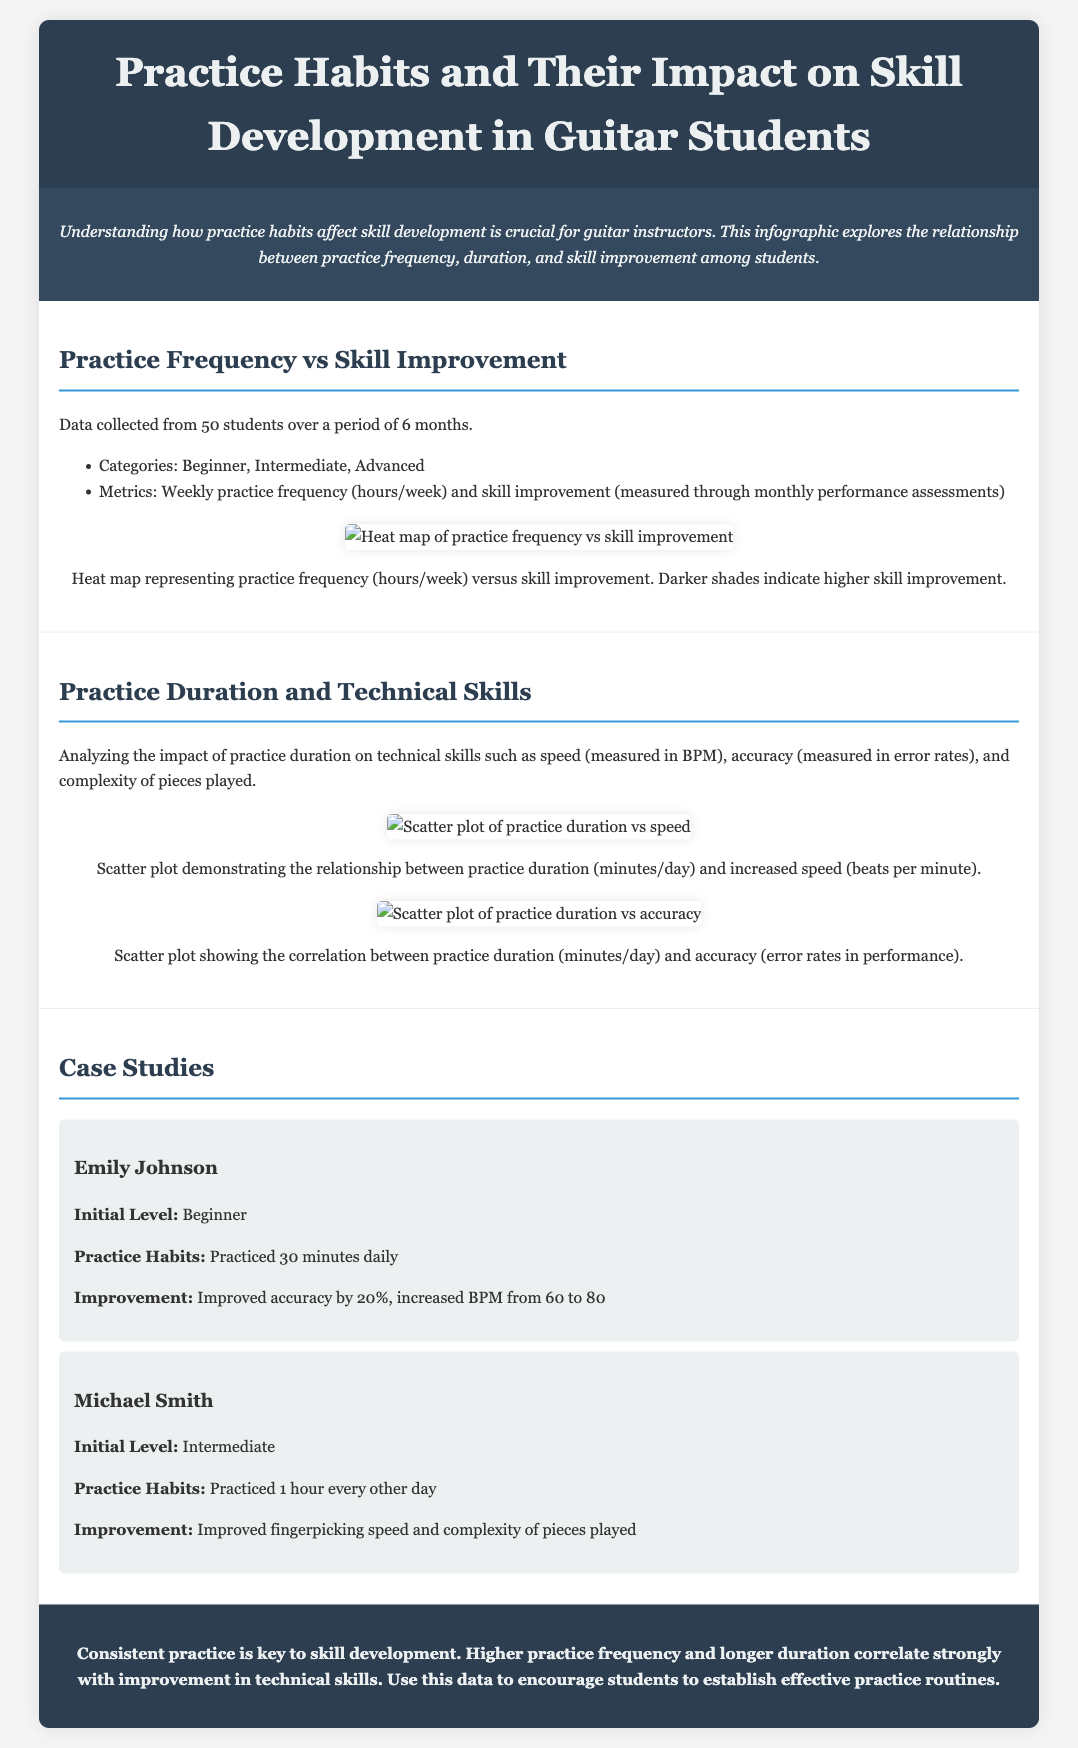what is the title of the infographic? The title of the infographic is stated in the header section, which summarizes the main topic of the document.
Answer: Practice Habits and Their Impact on Skill Development in Guitar Students how many students' data were collected? The document specifies that data was collected from a specific number of students over a defined period.
Answer: 50 what improvement did Emily Johnson achieve? The case study details the specific improvements Emily made in her skills after following her practice regimen.
Answer: Improved accuracy by 20% what was Michael Smith's initial skill level? The case study on Michael Smith mentions his starting point to understand his development in the context of the infographic.
Answer: Intermediate which technical skill is measured in BPM? The document discusses various metrics related to skills, and one specific metric is related to speed.
Answer: Speed what is the relationship depicted in the scatter plot images? The scatter plots in the document illustrate connections between practice habits and various skill metrics, requiring understanding of the visual relationships shown.
Answer: Practice duration and skill improvement which category is NOT mentioned in the practice frequency analysis? The document mentions specific categories when analyzing practice habits, leading to an understanding of the data segmentation.
Answer: Expert what is the color coding significance in the heat map? The heat map represents data visually using color gradients, with darker shades indicating different levels of skill improvement.
Answer: Darker shades indicate higher skill improvement how often did Emily Johnson practice? The case studies describe Emily's frequency of practice to give context to her skill development progress.
Answer: 30 minutes daily 